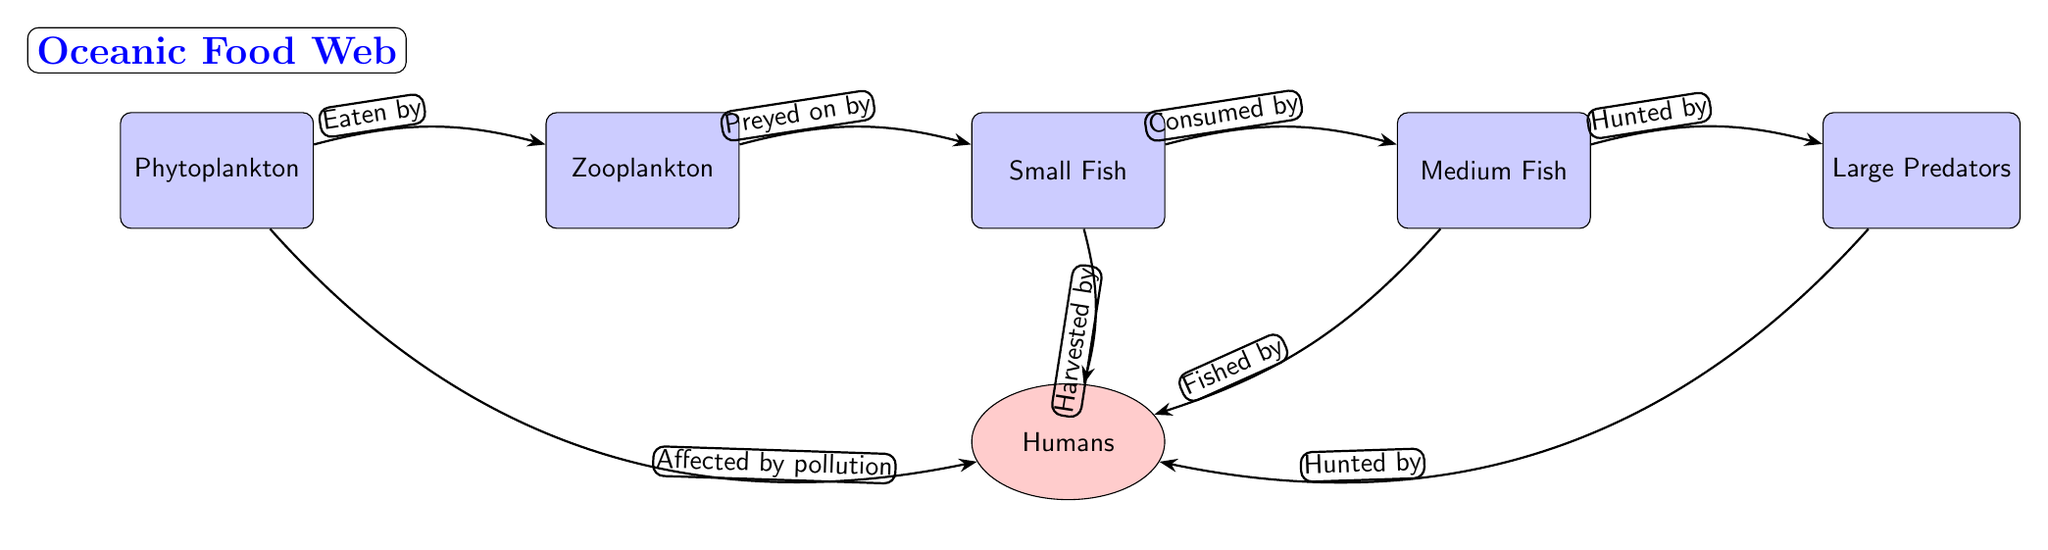What is the primary producer in the food web? The primary producer is represented by the first node in the diagram, which is "Phytoplankton." Since they are at the beginning, they form the base of the food web.
Answer: Phytoplankton How many types of fish are represented in the food web? There are three types of fish in the diagram: "Small Fish," "Medium Fish," and "Large Predators." Counting these nodes gives us the answer.
Answer: Three Who are the top predators in the marine ecosystem depicted in this food web? The top predators are represented by the last node in the diagram, which are "Large Predators." They are at the top of the food chain as they do not have other consumers above them in this diagram.
Answer: Large Predators What type of human activity is affecting the phytoplankton? The arrow labeled "Affected by pollution" indicates that human activities have an impact on the phytoplankton. This shows the relationship between humans and phytoplankton specifically through pollution.
Answer: Pollution How do small fish interact with humans in the food web? The interaction is shown by the edge labeled "Harvested by," which indicates that small fish are caught by humans for food or other purposes. This illustrates the impact of human activities on small fish.
Answer: Harvested by Which organism is preyed upon by small fish? The diagram shows that "Zooplankton" is linked to small fish through the label "Preyed on by." This indicates that small fish consume zooplankton, demonstrating their role in the food web as secondary consumers.
Answer: Zooplankton What is the relationship between medium fish and large predators? The relationship is indicated by the edge labeled "Hunted by," which shows that large predators consume medium fish, highlighting the predator-prey dynamic in the food web.
Answer: Hunted by Are humans depicted as predators in this food web? Yes, the diagram shows multiple relationships where humans are involved in harvesting and hunting different marine species, including "Small Fish," "Medium Fish," and "Large Predators," indicating that they act as predators in this ecosystem.
Answer: Yes What process is indicated by the edge between phytoplankton and zooplankton? The diagram identifies this process as "Eaten by," demonstrating that zooplankton feed on phytoplankton. This is an essential step in the energy transfer within the marine food web.
Answer: Eaten by 